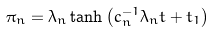<formula> <loc_0><loc_0><loc_500><loc_500>\pi _ { n } = \lambda _ { n } \tanh \left ( c _ { n } ^ { - 1 } \lambda _ { n } t + t _ { 1 } \right )</formula> 